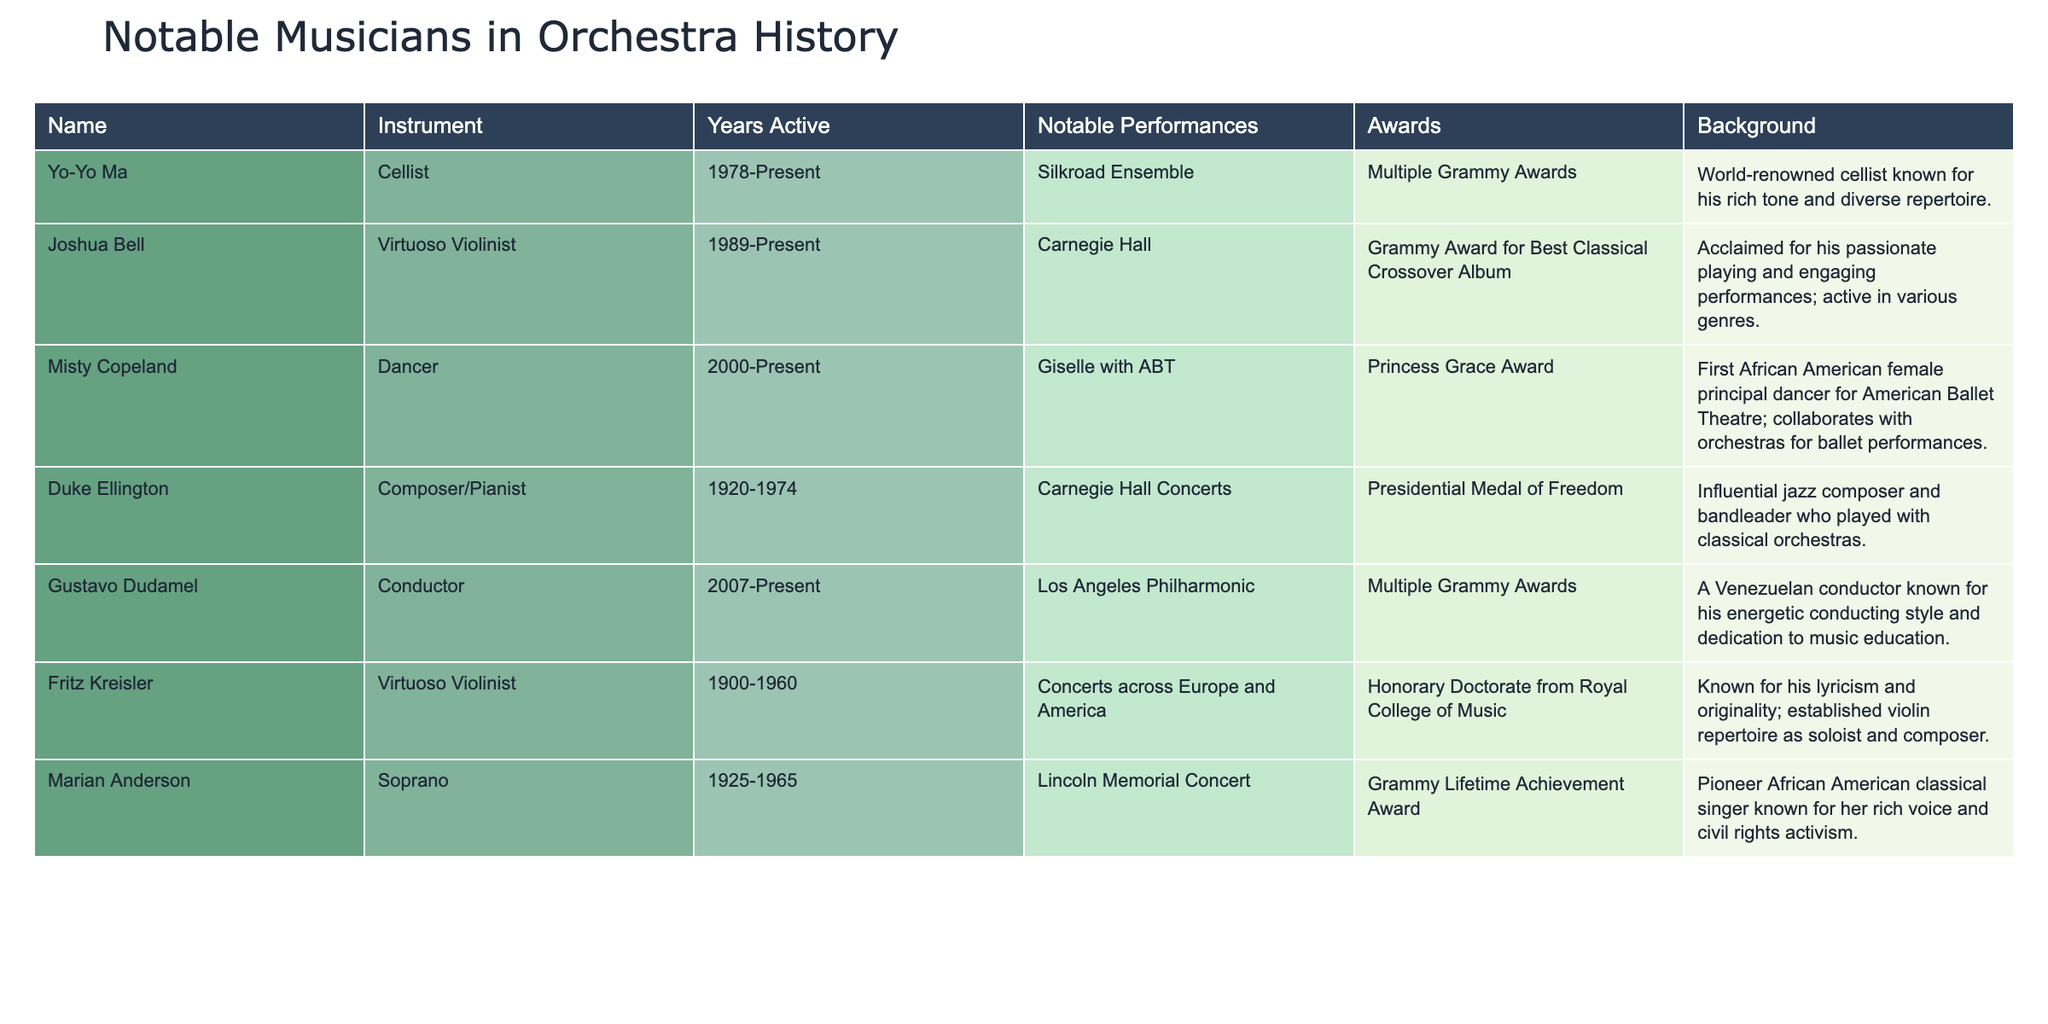What instrument does Yo-Yo Ma play? Yo-Yo Ma is listed under the "Name" column as a cellist in the "Instrument" column.
Answer: Cello How many Grammy Awards has Gustavo Dudamel received? The table states that Gustavo Dudamel has received multiple Grammy Awards, but does not specify an exact number.
Answer: Multiple Did Duke Ellington receive any awards? The table shows that Duke Ellington was awarded the Presidential Medal of Freedom, so the answer is yes.
Answer: Yes Who has been active the longest in the orchestra's history? When comparing the "Years Active" column, Duke Ellington's years span from 1920 to 1974, while others have more recent starting years, making him the longest.
Answer: Duke Ellington What is the background of Misty Copeland? The table indicates that Misty Copeland is known as the first African American female principal dancer for the American Ballet Theatre and collaborates with orchestras for ballet performances.
Answer: First African American female principal dancer for ABT; collaborates with orchestras What is the notable performance of Fritz Kreisler? According to the "Notable Performances" column, Fritz Kreisler performed at concerts across Europe and America, underscoring his widespread appeal and participation.
Answer: Concerts across Europe and America Which musician received the Grammy Lifetime Achievement Award? The table specifically states that Marian Anderson received the Grammy Lifetime Achievement Award, making this a clear retrieval from the data.
Answer: Marian Anderson How many notable performances did Joshua Bell have at Carnegie Hall? The table shows that Joshua Bell has had notable performances at Carnegie Hall; however, it does not specify an exact number of performances.
Answer: Not specified Which composers or musicians have won Grammy Awards? Referring to the "Awards" column, both Gustavo Dudamel and Joshua Bell have been identified as having received Grammy Awards. Therefore, there are multiple musicians who have won.
Answer: Gustavo Dudamel, Joshua Bell Is there any musician associated with ballet performances? The table clearly identifies Misty Copeland as a dancer associated with ballet performances and collaborations with orchestras, affirming the connection.
Answer: Yes 